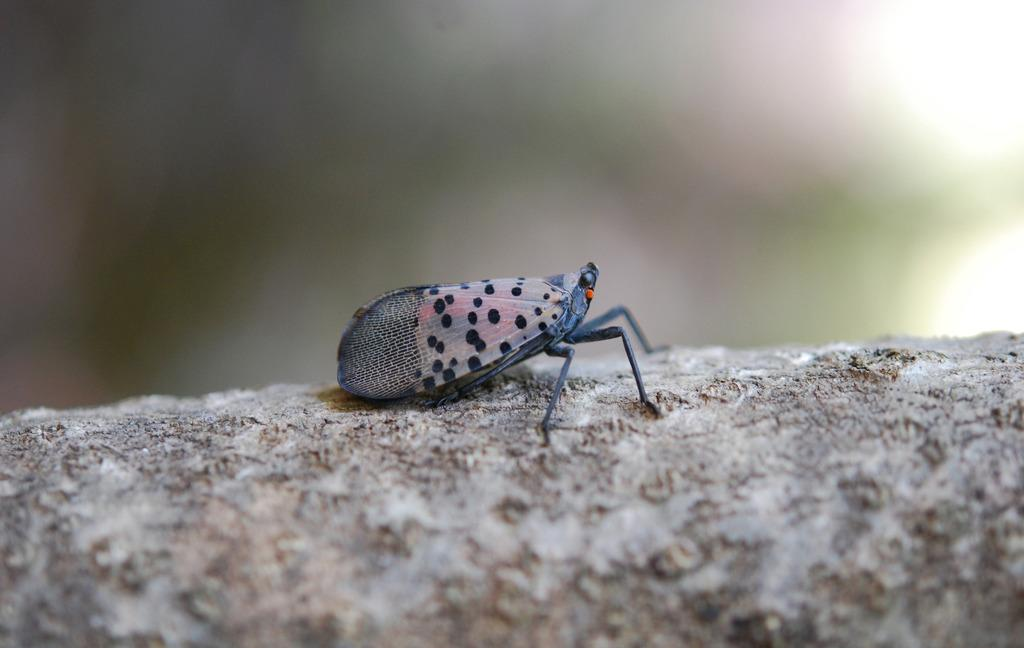What type of creature can be seen in the image? There is an insect in the image. What is the insect situated on in the image? The insect is on an object. Can you describe the background of the image? The background of the image is blurred. What type of rings can be seen on the tomatoes in the image? There are no tomatoes or rings present in the image. 